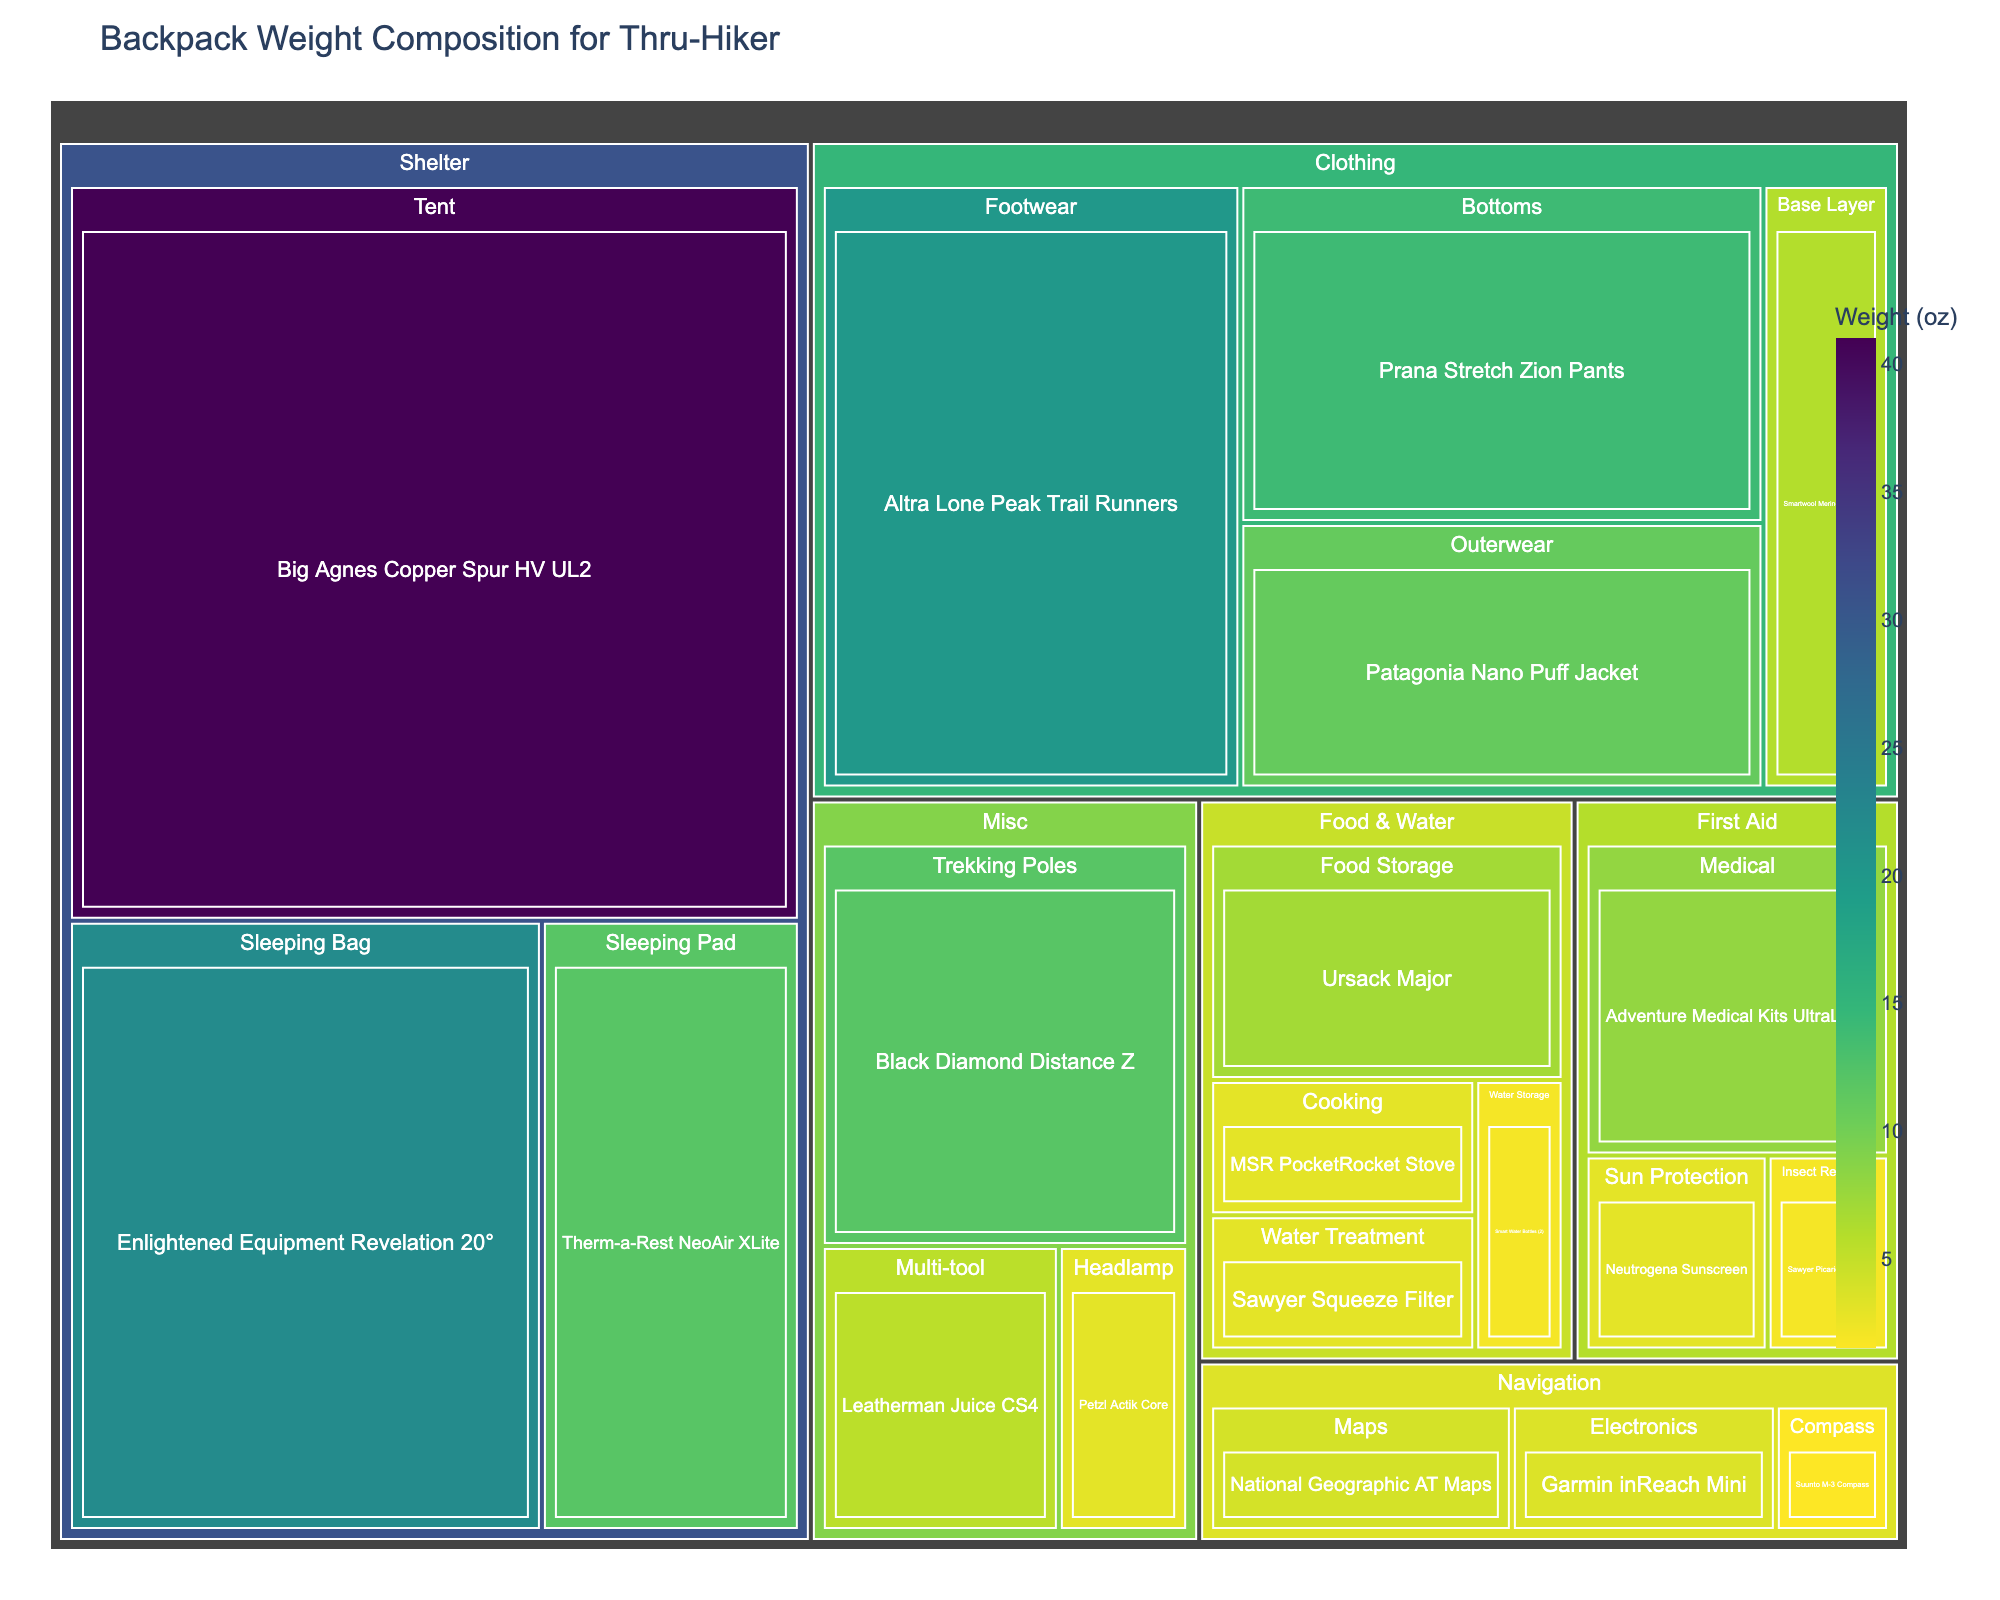What is the title of the plot? The title is displayed prominently at the top of the tree map.
Answer: Backpack Weight Composition for Thru-Hiker Which item under "First Aid" has the highest weight? By locating the "First Aid" category in the tree map and observing the weights of the items within it, the "Adventure Medical Kits UltraLight" has the highest weight.
Answer: Adventure Medical Kits UltraLight What is the combined weight of the "Patagonia Nano Puff Jacket" and "Prana Stretch Zion Pants"? The weights of the "Patagonia Nano Puff Jacket" and "Prana Stretch Zion Pants" are 11 oz and 14 oz respectively. Adding these gives 25 oz.
Answer: 25 oz Which category has the item with the maximum weight, and what is that item? By reviewing the weights in each category, the "Shelter" category contains the item with the maximum weight, which is the "Big Agnes Copper Spur HV UL2" at 41 oz.
Answer: Shelter, Big Agnes Copper Spur HV UL2 How does the weight of the "Garmin inReach Mini" compare with the "Suunto M-3 Compass"? The "Garmin inReach Mini" is 3.5 oz and the "Suunto M-3 Compass" is 1.5 oz. Therefore, the "Garmin inReach Mini" is 2 oz heavier than the "Suunto M-3 Compass".
Answer: Garmin inReach Mini is 2 oz heavier Which item in the "Food & Water" subcategory "Water Storage" is depicted in the figure, and what is its weight? Under the "Food & Water" category and the "Water Storage" subcategory, the item "Smart Water Bottles (2)" is shown with a weight of 2 oz.
Answer: Smart Water Bottles (2), 2 oz What is the total weight of all items listed under "Misc"? The "Misc" category contains three items: Black Diamond Distance Z (12 oz), Petzl Actik Core (3 oz), and Leatherman Juice CS4 (5.5 oz). The total weight is 12 + 3 + 5.5 = 20.5 oz.
Answer: 20.5 oz What is the average weight of the items under the "Clothing" category? Adding the weights of items in the "Clothing" category (11, 6, 14, and 20) gives a total of 51 oz. There are 4 items, so the average weight is 51 / 4 = 12.75 oz.
Answer: 12.75 oz Which has a higher weight: "Tent" or "Sleeping Bag" in the "Shelter" category, and by how much? Within the "Shelter" category, the "Tent" (41 oz) is heavier than the "Sleeping Bag" (22 oz). The difference is 41 - 22 = 19 oz.
Answer: Tent is heavier by 19 oz What proportion of the total backpack weight is contributed by the "Trekking Poles"? First, calculate the total weight of all items. Then the weight of the "Trekking Poles" (12 oz) can be divided by this total and converted into a proportion.
Answer: (12 oz / total weight) proportion 